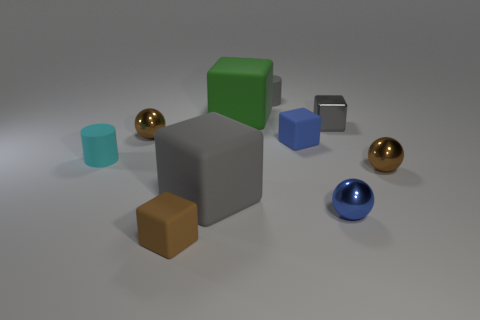There is a metallic cube; is its color the same as the metallic ball that is behind the cyan rubber thing?
Ensure brevity in your answer.  No. What color is the small rubber block that is behind the tiny blue thing in front of the tiny cyan object?
Your response must be concise. Blue. What number of cylinders are there?
Give a very brief answer. 2. How many matte things are cyan things or small gray blocks?
Offer a terse response. 1. What number of objects have the same color as the tiny metallic cube?
Provide a succinct answer. 2. What material is the small brown object to the right of the metallic block in front of the large green matte object?
Make the answer very short. Metal. The green thing is what size?
Offer a very short reply. Large. What number of yellow metallic blocks are the same size as the gray cylinder?
Ensure brevity in your answer.  0. What number of other shiny objects have the same shape as the large gray object?
Your answer should be very brief. 1. Are there an equal number of blue spheres behind the tiny cyan rubber object and large cyan blocks?
Offer a very short reply. Yes. 